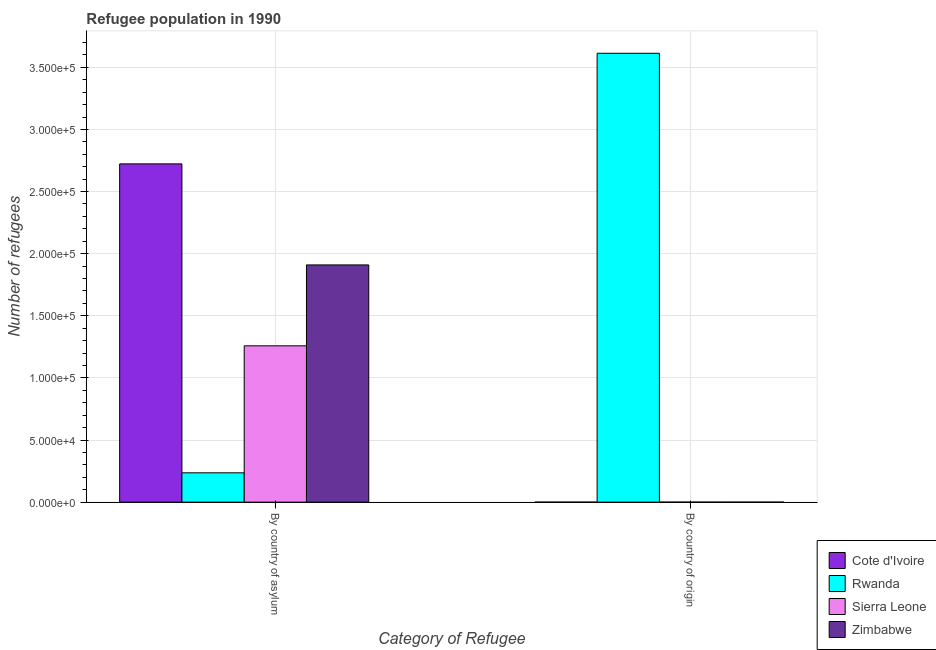How many groups of bars are there?
Provide a short and direct response. 2. Are the number of bars per tick equal to the number of legend labels?
Offer a terse response. Yes. What is the label of the 2nd group of bars from the left?
Ensure brevity in your answer.  By country of origin. What is the number of refugees by country of asylum in Cote d'Ivoire?
Give a very brief answer. 2.72e+05. Across all countries, what is the maximum number of refugees by country of asylum?
Your response must be concise. 2.72e+05. Across all countries, what is the minimum number of refugees by country of origin?
Your response must be concise. 2. In which country was the number of refugees by country of asylum maximum?
Ensure brevity in your answer.  Cote d'Ivoire. In which country was the number of refugees by country of asylum minimum?
Your answer should be compact. Rwanda. What is the total number of refugees by country of origin in the graph?
Offer a terse response. 3.61e+05. What is the difference between the number of refugees by country of asylum in Zimbabwe and that in Rwanda?
Your answer should be compact. 1.67e+05. What is the difference between the number of refugees by country of origin in Sierra Leone and the number of refugees by country of asylum in Zimbabwe?
Provide a succinct answer. -1.91e+05. What is the average number of refugees by country of origin per country?
Provide a succinct answer. 9.03e+04. What is the difference between the number of refugees by country of asylum and number of refugees by country of origin in Zimbabwe?
Your answer should be compact. 1.91e+05. What is the ratio of the number of refugees by country of origin in Sierra Leone to that in Cote d'Ivoire?
Your answer should be compact. 4.5. Is the number of refugees by country of asylum in Rwanda less than that in Zimbabwe?
Offer a very short reply. Yes. In how many countries, is the number of refugees by country of asylum greater than the average number of refugees by country of asylum taken over all countries?
Your response must be concise. 2. What does the 1st bar from the left in By country of asylum represents?
Make the answer very short. Cote d'Ivoire. What does the 2nd bar from the right in By country of origin represents?
Your answer should be very brief. Sierra Leone. How many countries are there in the graph?
Give a very brief answer. 4. Are the values on the major ticks of Y-axis written in scientific E-notation?
Your answer should be compact. Yes. Does the graph contain any zero values?
Your answer should be very brief. No. Does the graph contain grids?
Keep it short and to the point. Yes. What is the title of the graph?
Your answer should be very brief. Refugee population in 1990. What is the label or title of the X-axis?
Offer a terse response. Category of Refugee. What is the label or title of the Y-axis?
Offer a terse response. Number of refugees. What is the Number of refugees of Cote d'Ivoire in By country of asylum?
Provide a succinct answer. 2.72e+05. What is the Number of refugees of Rwanda in By country of asylum?
Offer a very short reply. 2.36e+04. What is the Number of refugees of Sierra Leone in By country of asylum?
Make the answer very short. 1.26e+05. What is the Number of refugees in Zimbabwe in By country of asylum?
Keep it short and to the point. 1.91e+05. What is the Number of refugees in Cote d'Ivoire in By country of origin?
Offer a terse response. 2. What is the Number of refugees in Rwanda in By country of origin?
Give a very brief answer. 3.61e+05. What is the Number of refugees in Sierra Leone in By country of origin?
Provide a short and direct response. 9. What is the Number of refugees in Zimbabwe in By country of origin?
Ensure brevity in your answer.  4. Across all Category of Refugee, what is the maximum Number of refugees of Cote d'Ivoire?
Give a very brief answer. 2.72e+05. Across all Category of Refugee, what is the maximum Number of refugees in Rwanda?
Your response must be concise. 3.61e+05. Across all Category of Refugee, what is the maximum Number of refugees of Sierra Leone?
Ensure brevity in your answer.  1.26e+05. Across all Category of Refugee, what is the maximum Number of refugees of Zimbabwe?
Give a very brief answer. 1.91e+05. Across all Category of Refugee, what is the minimum Number of refugees of Rwanda?
Give a very brief answer. 2.36e+04. What is the total Number of refugees in Cote d'Ivoire in the graph?
Provide a succinct answer. 2.72e+05. What is the total Number of refugees in Rwanda in the graph?
Ensure brevity in your answer.  3.85e+05. What is the total Number of refugees of Sierra Leone in the graph?
Your answer should be compact. 1.26e+05. What is the total Number of refugees of Zimbabwe in the graph?
Provide a succinct answer. 1.91e+05. What is the difference between the Number of refugees of Cote d'Ivoire in By country of asylum and that in By country of origin?
Your response must be concise. 2.72e+05. What is the difference between the Number of refugees of Rwanda in By country of asylum and that in By country of origin?
Give a very brief answer. -3.38e+05. What is the difference between the Number of refugees in Sierra Leone in By country of asylum and that in By country of origin?
Offer a very short reply. 1.26e+05. What is the difference between the Number of refugees in Zimbabwe in By country of asylum and that in By country of origin?
Ensure brevity in your answer.  1.91e+05. What is the difference between the Number of refugees of Cote d'Ivoire in By country of asylum and the Number of refugees of Rwanda in By country of origin?
Keep it short and to the point. -8.90e+04. What is the difference between the Number of refugees of Cote d'Ivoire in By country of asylum and the Number of refugees of Sierra Leone in By country of origin?
Provide a succinct answer. 2.72e+05. What is the difference between the Number of refugees in Cote d'Ivoire in By country of asylum and the Number of refugees in Zimbabwe in By country of origin?
Make the answer very short. 2.72e+05. What is the difference between the Number of refugees in Rwanda in By country of asylum and the Number of refugees in Sierra Leone in By country of origin?
Provide a short and direct response. 2.36e+04. What is the difference between the Number of refugees in Rwanda in By country of asylum and the Number of refugees in Zimbabwe in By country of origin?
Ensure brevity in your answer.  2.36e+04. What is the difference between the Number of refugees of Sierra Leone in By country of asylum and the Number of refugees of Zimbabwe in By country of origin?
Your answer should be compact. 1.26e+05. What is the average Number of refugees in Cote d'Ivoire per Category of Refugee?
Your answer should be compact. 1.36e+05. What is the average Number of refugees in Rwanda per Category of Refugee?
Ensure brevity in your answer.  1.92e+05. What is the average Number of refugees in Sierra Leone per Category of Refugee?
Offer a terse response. 6.29e+04. What is the average Number of refugees of Zimbabwe per Category of Refugee?
Your answer should be compact. 9.55e+04. What is the difference between the Number of refugees of Cote d'Ivoire and Number of refugees of Rwanda in By country of asylum?
Offer a very short reply. 2.49e+05. What is the difference between the Number of refugees of Cote d'Ivoire and Number of refugees of Sierra Leone in By country of asylum?
Offer a very short reply. 1.46e+05. What is the difference between the Number of refugees in Cote d'Ivoire and Number of refugees in Zimbabwe in By country of asylum?
Make the answer very short. 8.13e+04. What is the difference between the Number of refugees of Rwanda and Number of refugees of Sierra Leone in By country of asylum?
Offer a terse response. -1.02e+05. What is the difference between the Number of refugees in Rwanda and Number of refugees in Zimbabwe in By country of asylum?
Your answer should be very brief. -1.67e+05. What is the difference between the Number of refugees in Sierra Leone and Number of refugees in Zimbabwe in By country of asylum?
Give a very brief answer. -6.51e+04. What is the difference between the Number of refugees of Cote d'Ivoire and Number of refugees of Rwanda in By country of origin?
Offer a terse response. -3.61e+05. What is the difference between the Number of refugees in Cote d'Ivoire and Number of refugees in Sierra Leone in By country of origin?
Offer a terse response. -7. What is the difference between the Number of refugees in Cote d'Ivoire and Number of refugees in Zimbabwe in By country of origin?
Make the answer very short. -2. What is the difference between the Number of refugees of Rwanda and Number of refugees of Sierra Leone in By country of origin?
Offer a terse response. 3.61e+05. What is the difference between the Number of refugees in Rwanda and Number of refugees in Zimbabwe in By country of origin?
Give a very brief answer. 3.61e+05. What is the difference between the Number of refugees of Sierra Leone and Number of refugees of Zimbabwe in By country of origin?
Offer a very short reply. 5. What is the ratio of the Number of refugees of Cote d'Ivoire in By country of asylum to that in By country of origin?
Make the answer very short. 1.36e+05. What is the ratio of the Number of refugees in Rwanda in By country of asylum to that in By country of origin?
Provide a short and direct response. 0.07. What is the ratio of the Number of refugees of Sierra Leone in By country of asylum to that in By country of origin?
Offer a very short reply. 1.40e+04. What is the ratio of the Number of refugees in Zimbabwe in By country of asylum to that in By country of origin?
Provide a succinct answer. 4.77e+04. What is the difference between the highest and the second highest Number of refugees in Cote d'Ivoire?
Ensure brevity in your answer.  2.72e+05. What is the difference between the highest and the second highest Number of refugees in Rwanda?
Make the answer very short. 3.38e+05. What is the difference between the highest and the second highest Number of refugees in Sierra Leone?
Your response must be concise. 1.26e+05. What is the difference between the highest and the second highest Number of refugees in Zimbabwe?
Your answer should be very brief. 1.91e+05. What is the difference between the highest and the lowest Number of refugees in Cote d'Ivoire?
Ensure brevity in your answer.  2.72e+05. What is the difference between the highest and the lowest Number of refugees of Rwanda?
Your answer should be compact. 3.38e+05. What is the difference between the highest and the lowest Number of refugees of Sierra Leone?
Provide a succinct answer. 1.26e+05. What is the difference between the highest and the lowest Number of refugees of Zimbabwe?
Your response must be concise. 1.91e+05. 